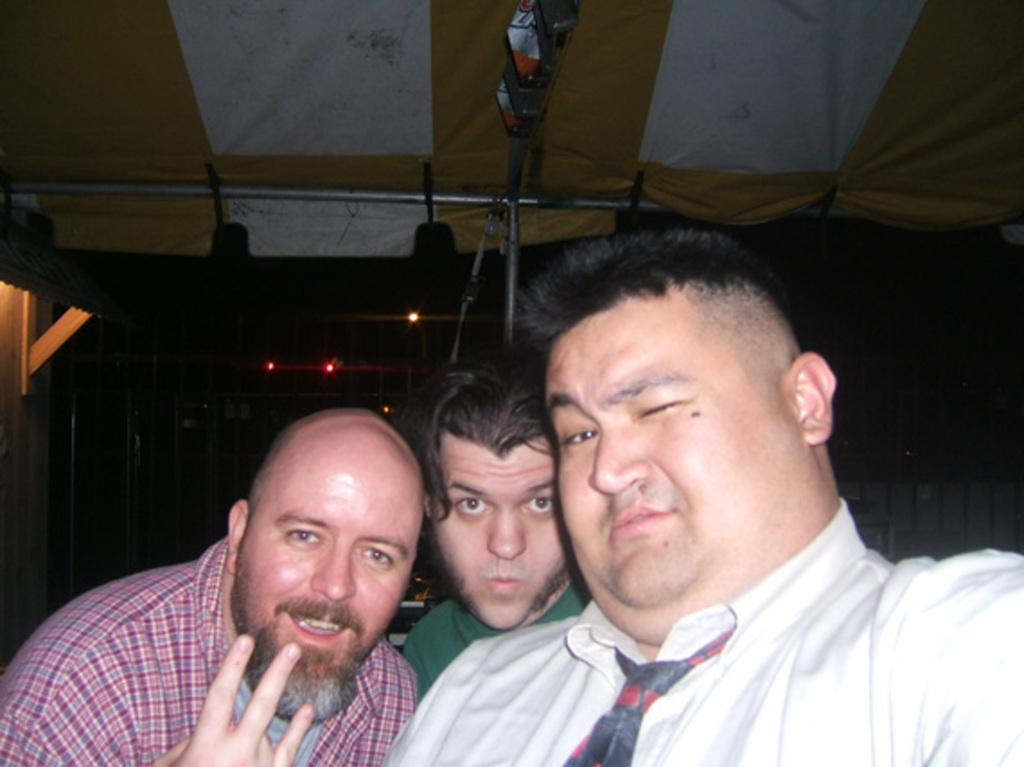How many people are in the image? There are three persons standing in the image. Where are the persons located in the image? The persons are standing at the bottom of the image. What can be seen in the background of the image? There is a shelter roof in the background of the image. What type of clover is growing near the shelter roof in the image? There is no clover visible in the image; the focus is on the three persons and the shelter roof. What action are the persons performing in the image? The provided facts do not specify any actions being performed by the persons; they are simply standing. 